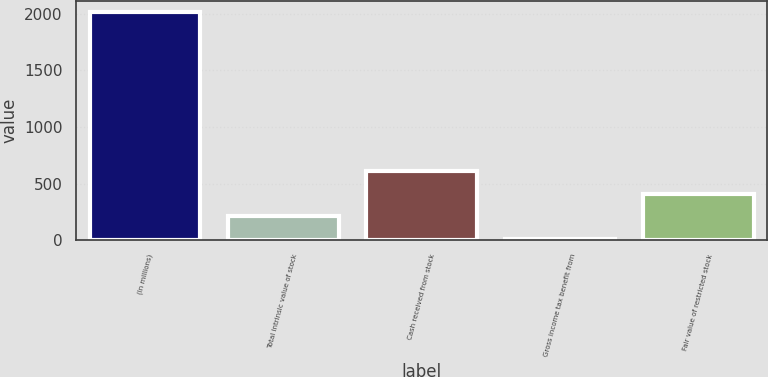Convert chart to OTSL. <chart><loc_0><loc_0><loc_500><loc_500><bar_chart><fcel>(In millions)<fcel>Total intrinsic value of stock<fcel>Cash received from stock<fcel>Gross income tax benefit from<fcel>Fair value of restricted stock<nl><fcel>2013<fcel>210.3<fcel>610.9<fcel>10<fcel>410.6<nl></chart> 